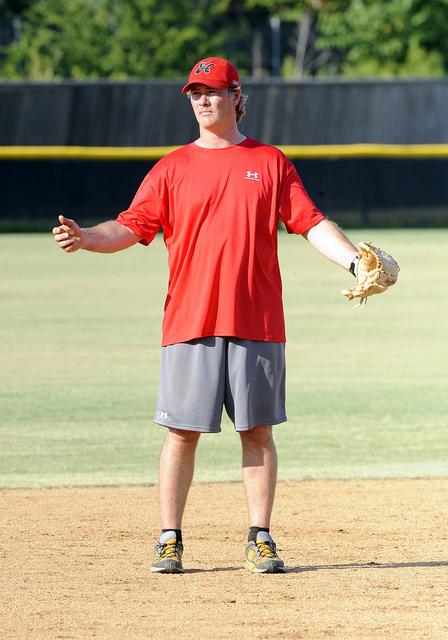What is the color of the player's socks?
Quick response, please. Black. What sport is the man playing?
Keep it brief. Baseball. What letter is on the front of the helmet?
Keep it brief. H. What color is his hat?
Write a very short answer. Red. What hand is wearing the glove?
Concise answer only. Left. 